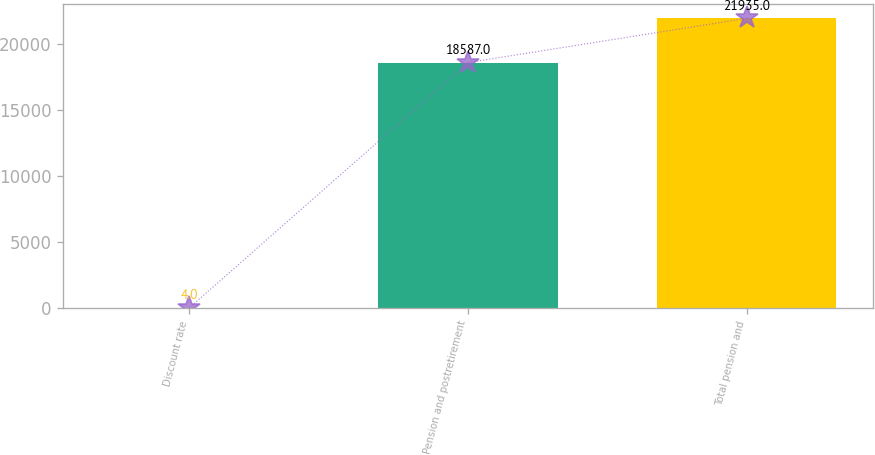Convert chart. <chart><loc_0><loc_0><loc_500><loc_500><bar_chart><fcel>Discount rate<fcel>Pension and postretirement<fcel>Total pension and<nl><fcel>4<fcel>18587<fcel>21935<nl></chart> 